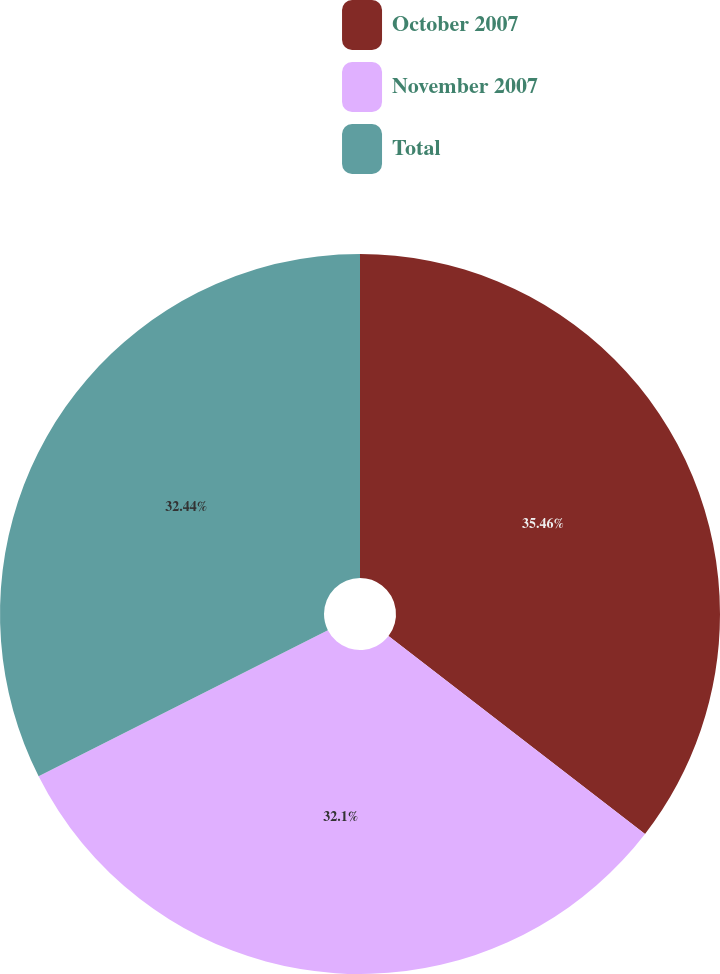<chart> <loc_0><loc_0><loc_500><loc_500><pie_chart><fcel>October 2007<fcel>November 2007<fcel>Total<nl><fcel>35.46%<fcel>32.1%<fcel>32.44%<nl></chart> 